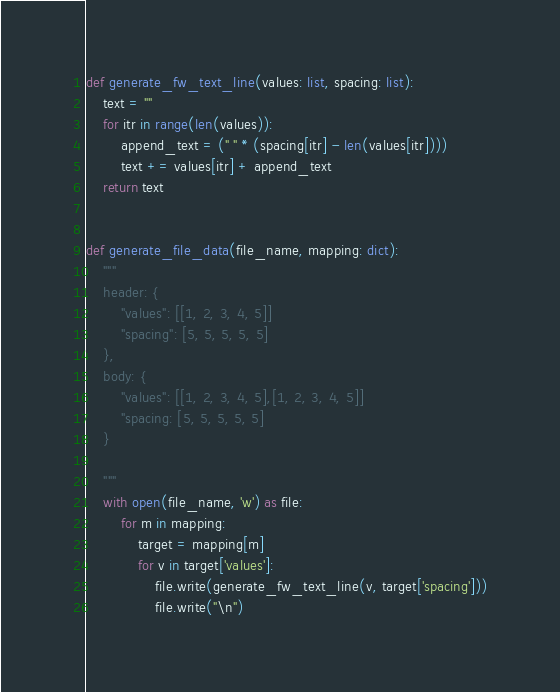<code> <loc_0><loc_0><loc_500><loc_500><_Python_>
def generate_fw_text_line(values: list, spacing: list):
    text = ""
    for itr in range(len(values)):
        append_text = (" " * (spacing[itr] - len(values[itr])))
        text += values[itr] + append_text
    return text


def generate_file_data(file_name, mapping: dict):
    """
    header: {
        "values": [[1, 2, 3, 4, 5]]
        "spacing": [5, 5, 5, 5, 5]
    },
    body: {
        "values": [[1, 2, 3, 4, 5],[1, 2, 3, 4, 5]]
        "spacing: [5, 5, 5, 5, 5]
    }

    """
    with open(file_name, 'w') as file:
        for m in mapping:
            target = mapping[m]
            for v in target['values']:
                file.write(generate_fw_text_line(v, target['spacing']))
                file.write("\n")

</code> 